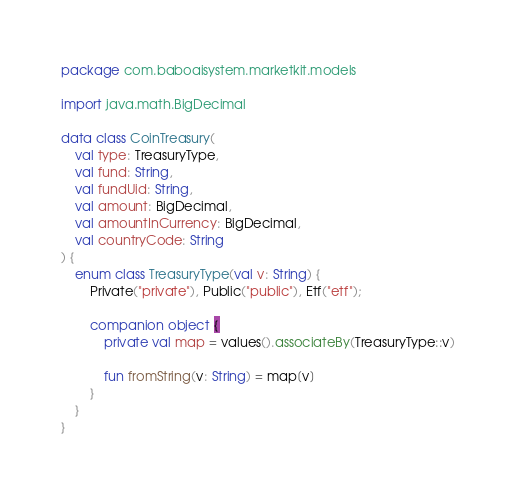Convert code to text. <code><loc_0><loc_0><loc_500><loc_500><_Kotlin_>package com.baboaisystem.marketkit.models

import java.math.BigDecimal

data class CoinTreasury(
    val type: TreasuryType,
    val fund: String,
    val fundUid: String,
    val amount: BigDecimal,
    val amountInCurrency: BigDecimal,
    val countryCode: String
) {
    enum class TreasuryType(val v: String) {
        Private("private"), Public("public"), Etf("etf");

        companion object {
            private val map = values().associateBy(TreasuryType::v)

            fun fromString(v: String) = map[v]
        }
    }
}
</code> 